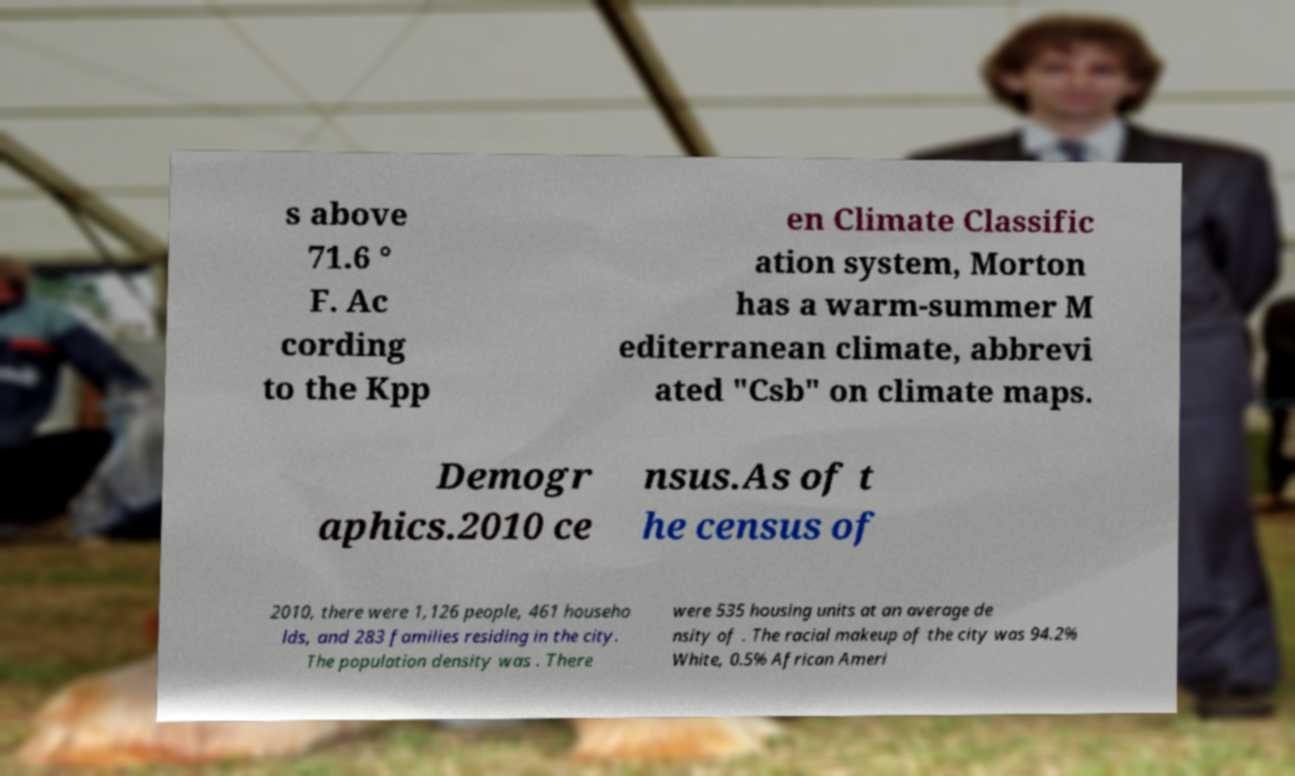I need the written content from this picture converted into text. Can you do that? s above 71.6 ° F. Ac cording to the Kpp en Climate Classific ation system, Morton has a warm-summer M editerranean climate, abbrevi ated "Csb" on climate maps. Demogr aphics.2010 ce nsus.As of t he census of 2010, there were 1,126 people, 461 househo lds, and 283 families residing in the city. The population density was . There were 535 housing units at an average de nsity of . The racial makeup of the city was 94.2% White, 0.5% African Ameri 